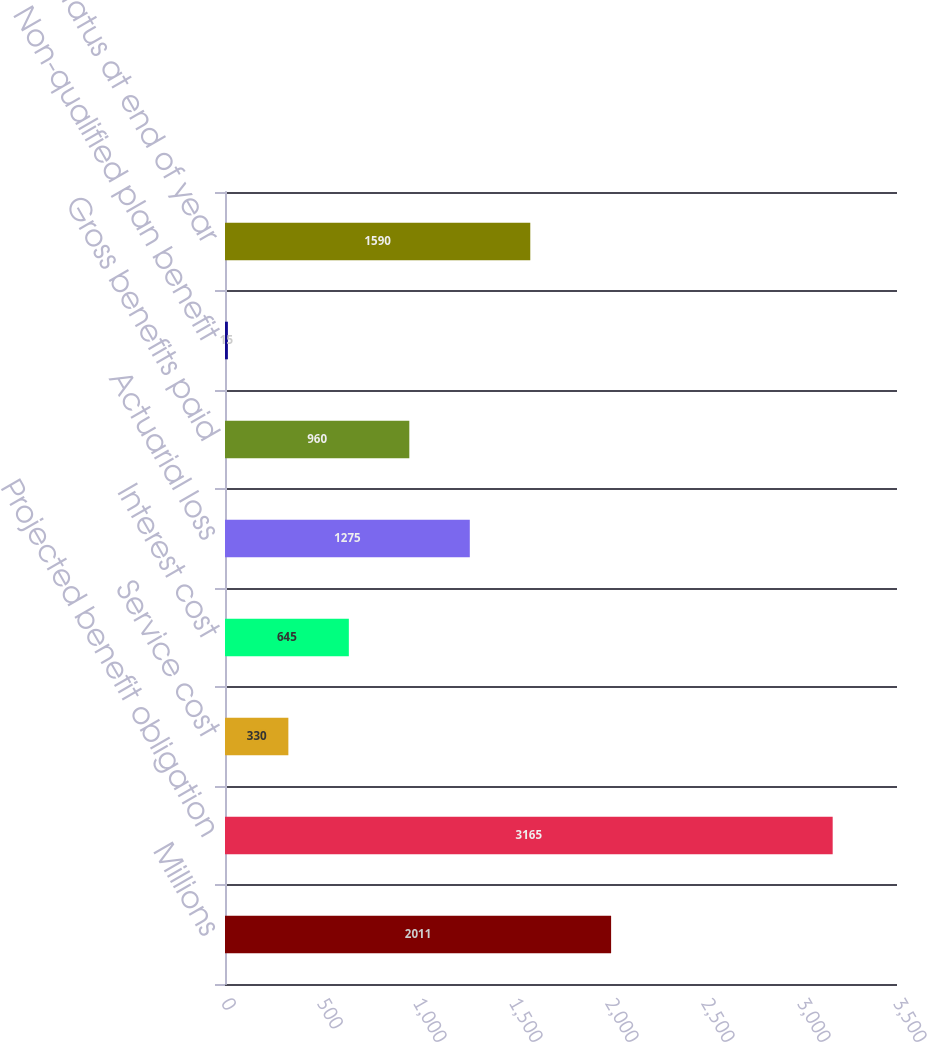Convert chart to OTSL. <chart><loc_0><loc_0><loc_500><loc_500><bar_chart><fcel>Millions<fcel>Projected benefit obligation<fcel>Service cost<fcel>Interest cost<fcel>Actuarial loss<fcel>Gross benefits paid<fcel>Non-qualified plan benefit<fcel>Funded status at end of year<nl><fcel>2011<fcel>3165<fcel>330<fcel>645<fcel>1275<fcel>960<fcel>15<fcel>1590<nl></chart> 